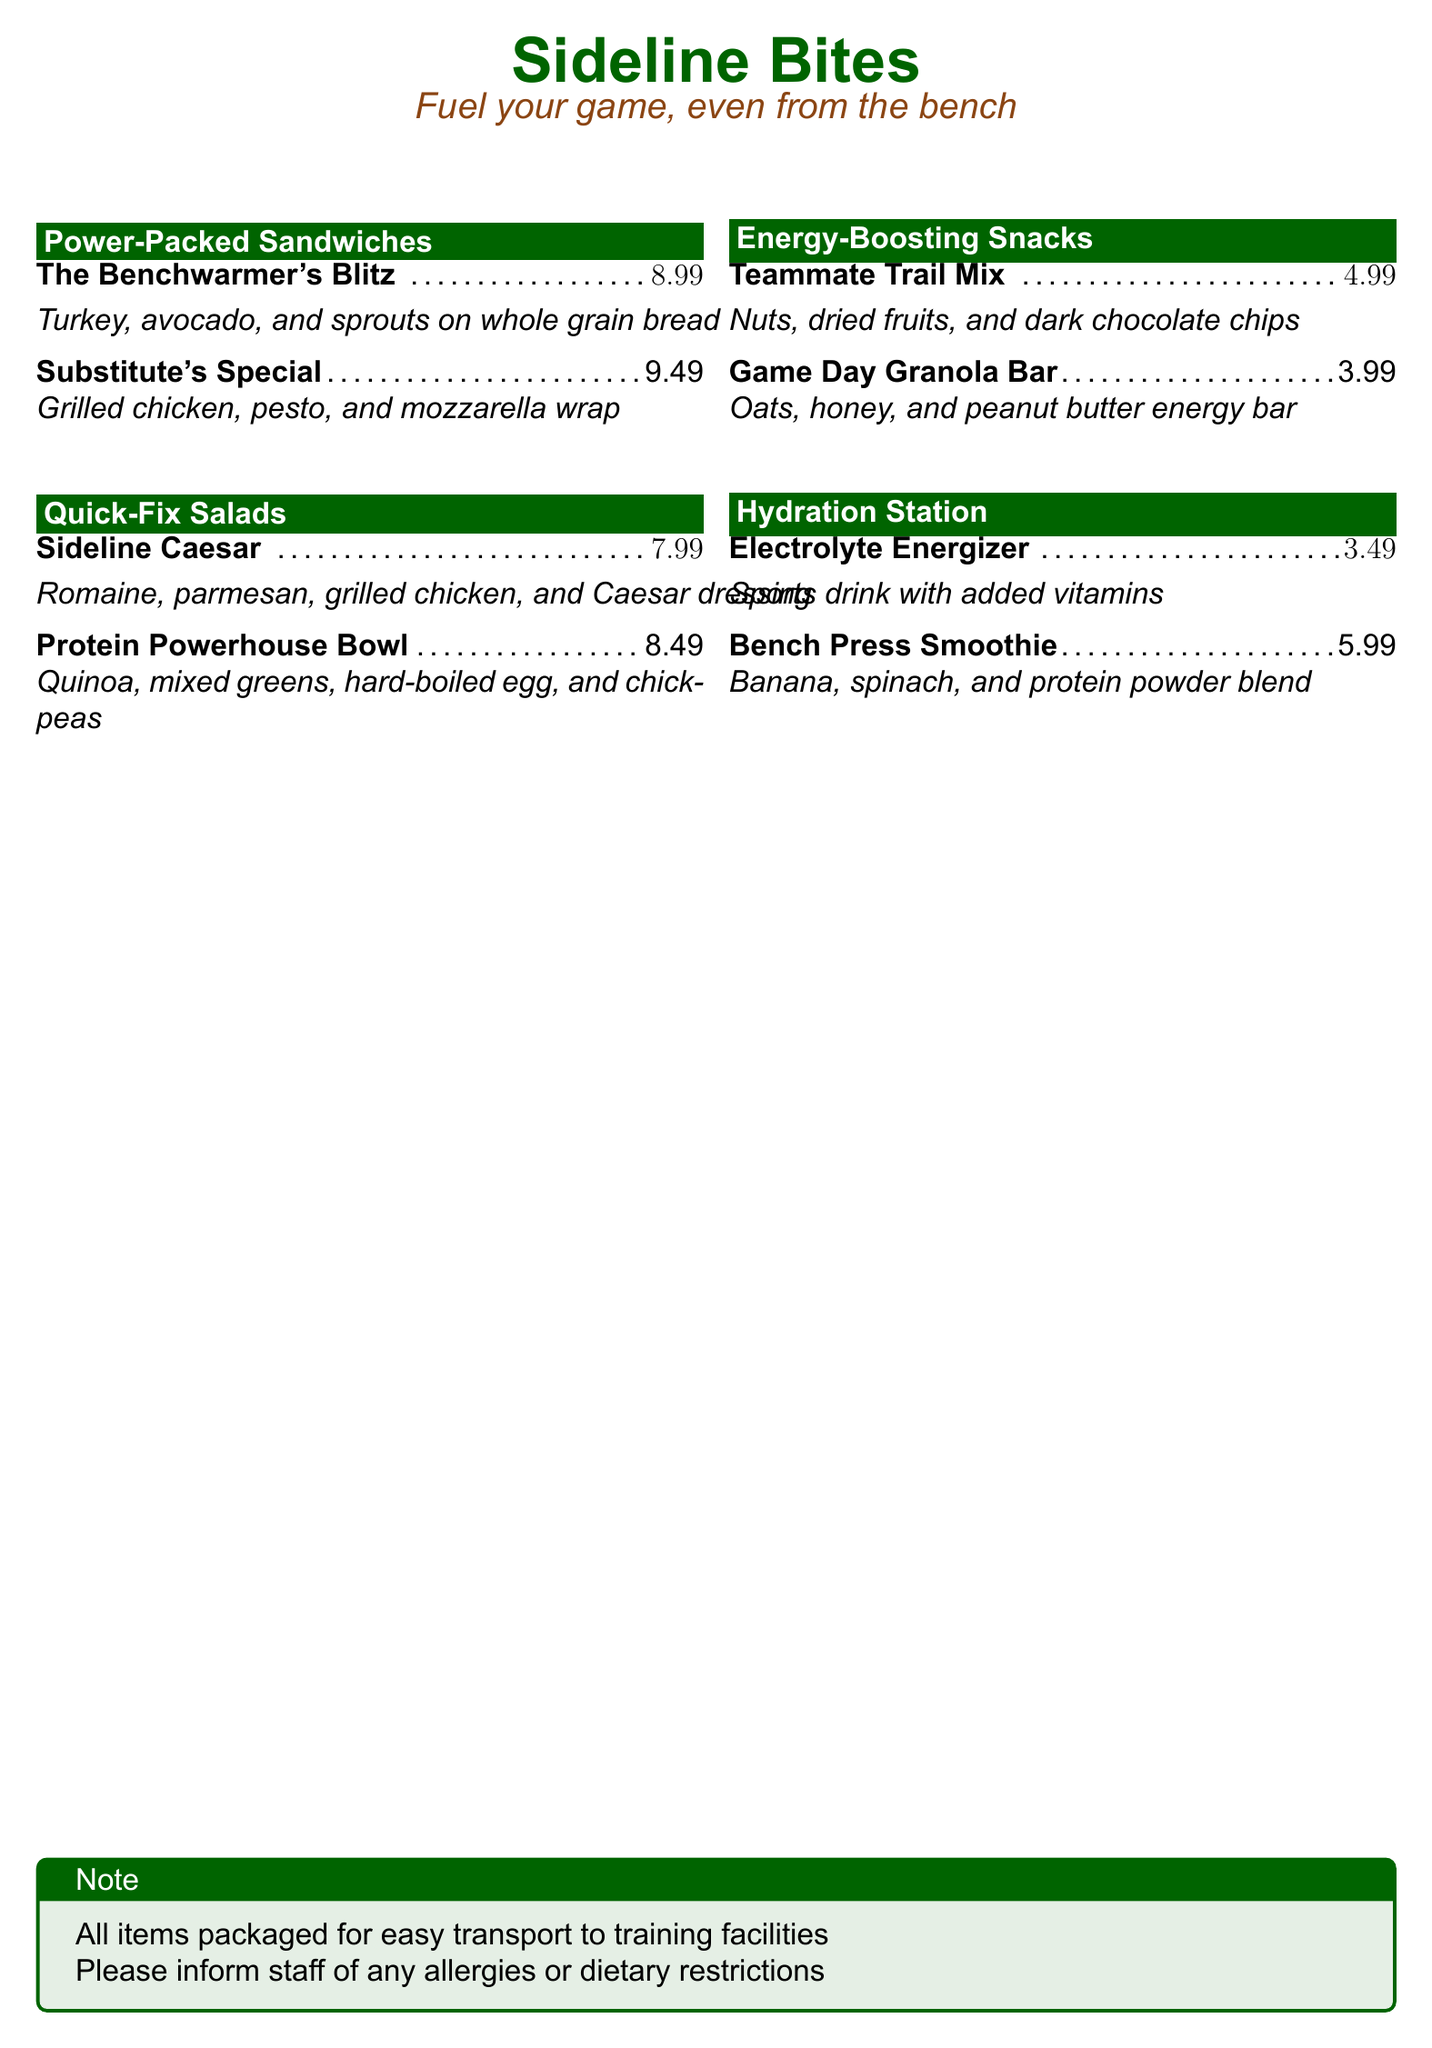What is the name of the salad that includes quinoa? The salad with quinoa is listed as "Protein Powerhouse Bowl".
Answer: Protein Powerhouse Bowl What is the price of the "Substitute's Special"? The price for the "Substitute's Special" sandwich is stated directly in the menu as $9.49.
Answer: $9.49 Which two items are categorized under "Energy-Boosting Snacks"? The items listed under "Energy-Boosting Snacks" are "Teammate Trail Mix" and "Game Day Granola Bar".
Answer: Teammate Trail Mix and Game Day Granola Bar How much does the "Bench Press Smoothie" cost? The cost of the "Bench Press Smoothie" is explicitly mentioned in the menu, which is $5.99.
Answer: $5.99 Which item contains hard-boiled egg? The item that contains hard-boiled egg is "Protein Powerhouse Bowl".
Answer: Protein Powerhouse Bowl What color is the document's title? The document's title color is indicated in the code and is described as "sideline", which is a shade of green.
Answer: Green What type of drinks does the menu feature? The menu features drinks categorized under "Hydration Station."
Answer: Hydration Station How many types of sandwiches are listed on the menu? The menu lists two types of sandwiches in the "Power-Packed Sandwiches" section.
Answer: Two What is the purpose of the packaging of the items? The note specifies that all items are packaged for easy transport to training facilities.
Answer: Easy transport 